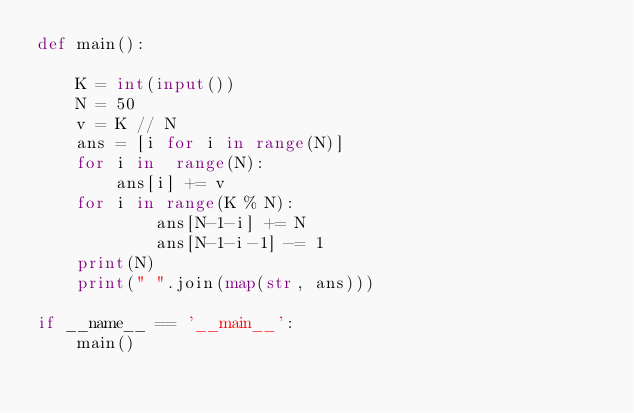<code> <loc_0><loc_0><loc_500><loc_500><_Python_>def main():

    K = int(input())
    N = 50
    v = K // N
    ans = [i for i in range(N)]
    for i in  range(N):
        ans[i] += v
    for i in range(K % N):
            ans[N-1-i] += N
            ans[N-1-i-1] -= 1
    print(N)
    print(" ".join(map(str, ans)))

if __name__ == '__main__':
    main()</code> 